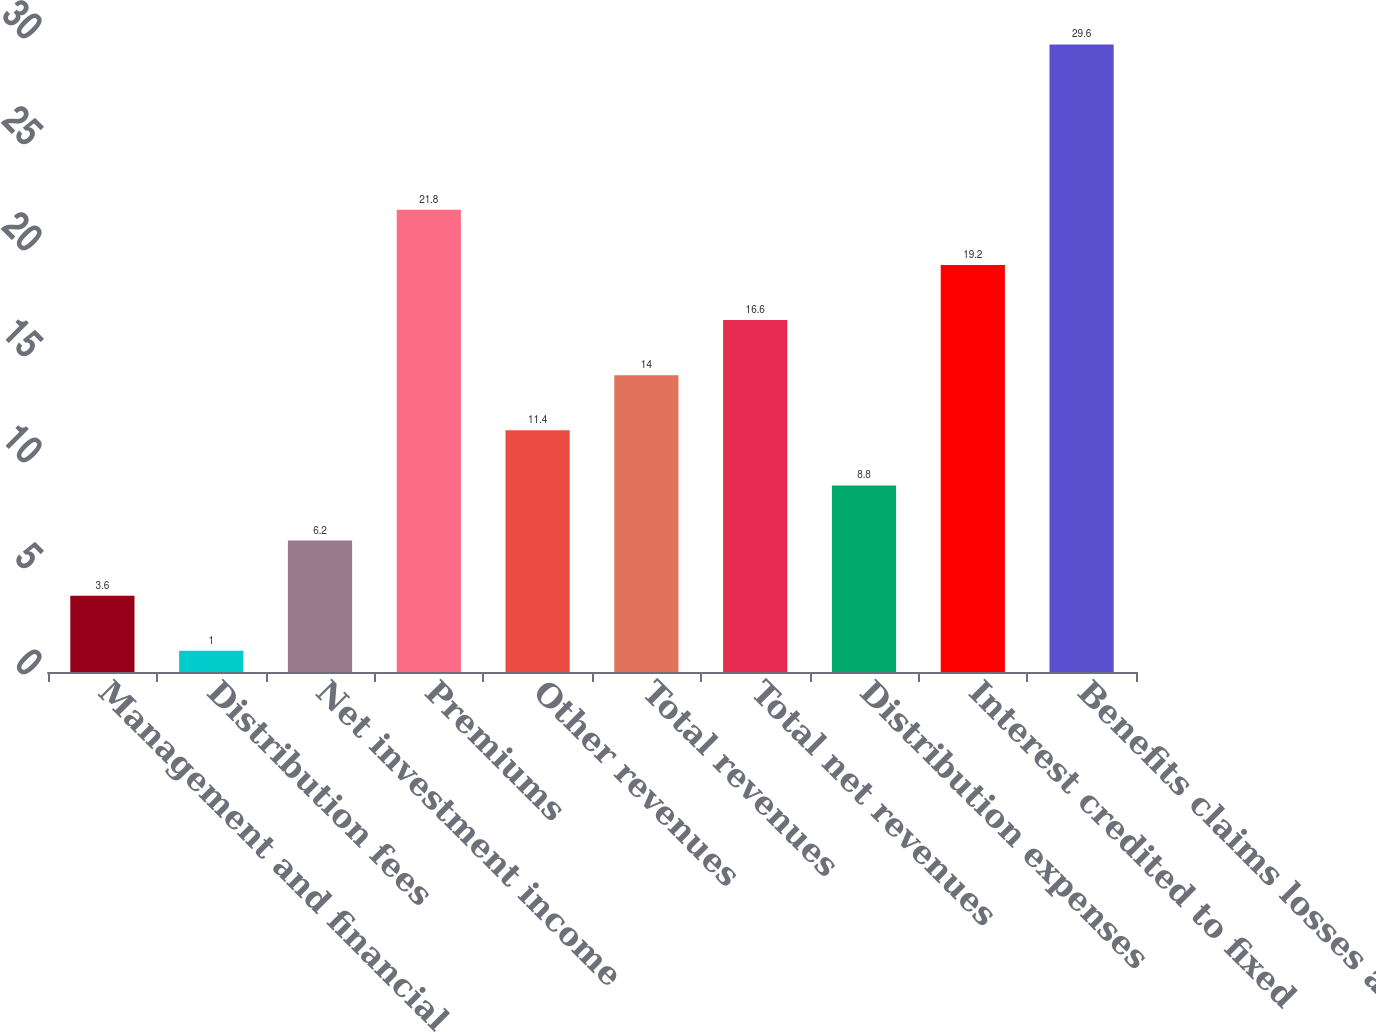Convert chart. <chart><loc_0><loc_0><loc_500><loc_500><bar_chart><fcel>Management and financial<fcel>Distribution fees<fcel>Net investment income<fcel>Premiums<fcel>Other revenues<fcel>Total revenues<fcel>Total net revenues<fcel>Distribution expenses<fcel>Interest credited to fixed<fcel>Benefits claims losses and<nl><fcel>3.6<fcel>1<fcel>6.2<fcel>21.8<fcel>11.4<fcel>14<fcel>16.6<fcel>8.8<fcel>19.2<fcel>29.6<nl></chart> 